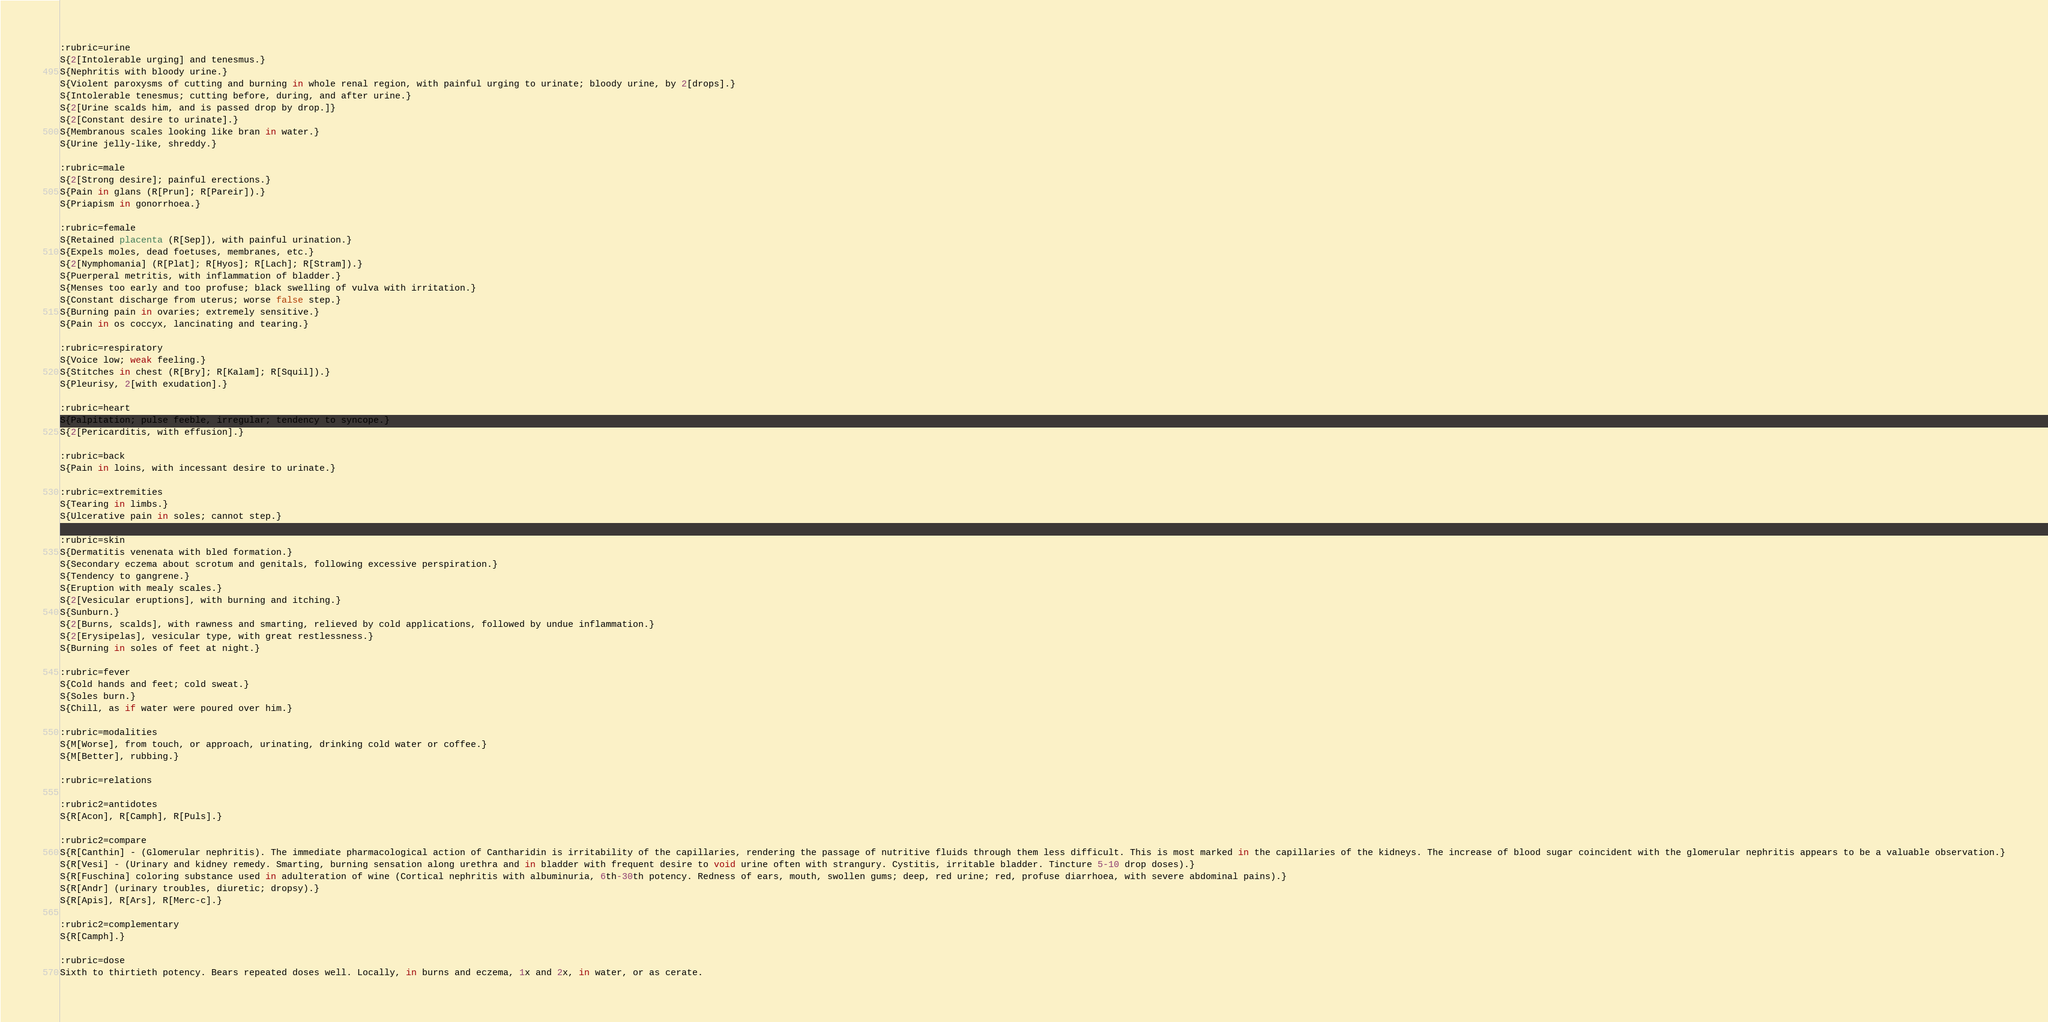Convert code to text. <code><loc_0><loc_0><loc_500><loc_500><_ObjectiveC_>:rubric=urine
S{2[Intolerable urging] and tenesmus.}
S{Nephritis with bloody urine.}
S{Violent paroxysms of cutting and burning in whole renal region, with painful urging to urinate; bloody urine, by 2[drops].}
S{Intolerable tenesmus; cutting before, during, and after urine.}
S{2[Urine scalds him, and is passed drop by drop.]}
S{2[Constant desire to urinate].}
S{Membranous scales looking like bran in water.}
S{Urine jelly-like, shreddy.}

:rubric=male
S{2[Strong desire]; painful erections.}
S{Pain in glans (R[Prun]; R[Pareir]).}
S{Priapism in gonorrhoea.}

:rubric=female
S{Retained placenta (R[Sep]), with painful urination.}
S{Expels moles, dead foetuses, membranes, etc.}
S{2[Nymphomania] (R[Plat]; R[Hyos]; R[Lach]; R[Stram]).}
S{Puerperal metritis, with inflammation of bladder.}
S{Menses too early and too profuse; black swelling of vulva with irritation.}
S{Constant discharge from uterus; worse false step.}
S{Burning pain in ovaries; extremely sensitive.}
S{Pain in os coccyx, lancinating and tearing.}

:rubric=respiratory
S{Voice low; weak feeling.}
S{Stitches in chest (R[Bry]; R[Kalam]; R[Squil]).}
S{Pleurisy, 2[with exudation].}

:rubric=heart
S{Palpitation; pulse feeble, irregular; tendency to syncope.}
S{2[Pericarditis, with effusion].}

:rubric=back
S{Pain in loins, with incessant desire to urinate.}

:rubric=extremities
S{Tearing in limbs.}
S{Ulcerative pain in soles; cannot step.}

:rubric=skin
S{Dermatitis venenata with bled formation.}
S{Secondary eczema about scrotum and genitals, following excessive perspiration.}
S{Tendency to gangrene.}
S{Eruption with mealy scales.}
S{2[Vesicular eruptions], with burning and itching.}
S{Sunburn.}
S{2[Burns, scalds], with rawness and smarting, relieved by cold applications, followed by undue inflammation.}
S{2[Erysipelas], vesicular type, with great restlessness.}
S{Burning in soles of feet at night.}

:rubric=fever
S{Cold hands and feet; cold sweat.}
S{Soles burn.}
S{Chill, as if water were poured over him.}

:rubric=modalities
S{M[Worse], from touch, or approach, urinating, drinking cold water or coffee.}
S{M[Better], rubbing.}

:rubric=relations

:rubric2=antidotes
S{R[Acon], R[Camph], R[Puls].}

:rubric2=compare
S{R[Canthin] - (Glomerular nephritis). The immediate pharmacological action of Cantharidin is irritability of the capillaries, rendering the passage of nutritive fluids through them less difficult. This is most marked in the capillaries of the kidneys. The increase of blood sugar coincident with the glomerular nephritis appears to be a valuable observation.}
S{R[Vesi] - (Urinary and kidney remedy. Smarting, burning sensation along urethra and in bladder with frequent desire to void urine often with strangury. Cystitis, irritable bladder. Tincture 5-10 drop doses).}
S{R[Fuschina] coloring substance used in adulteration of wine (Cortical nephritis with albuminuria, 6th-30th potency. Redness of ears, mouth, swollen gums; deep, red urine; red, profuse diarrhoea, with severe abdominal pains).}
S{R[Andr] (urinary troubles, diuretic; dropsy).}
S{R[Apis], R[Ars], R[Merc-c].}

:rubric2=complementary
S{R[Camph].}

:rubric=dose
Sixth to thirtieth potency. Bears repeated doses well. Locally, in burns and eczema, 1x and 2x, in water, or as cerate.</code> 